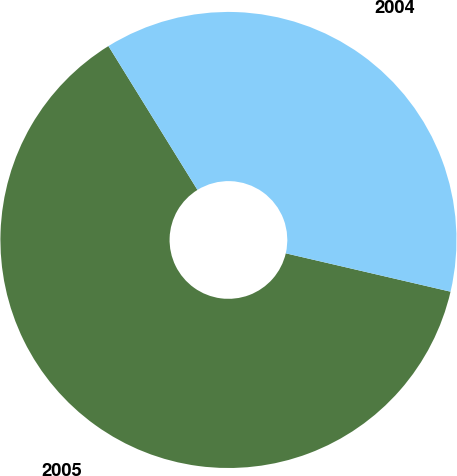<chart> <loc_0><loc_0><loc_500><loc_500><pie_chart><fcel>2005<fcel>2004<nl><fcel>62.54%<fcel>37.46%<nl></chart> 